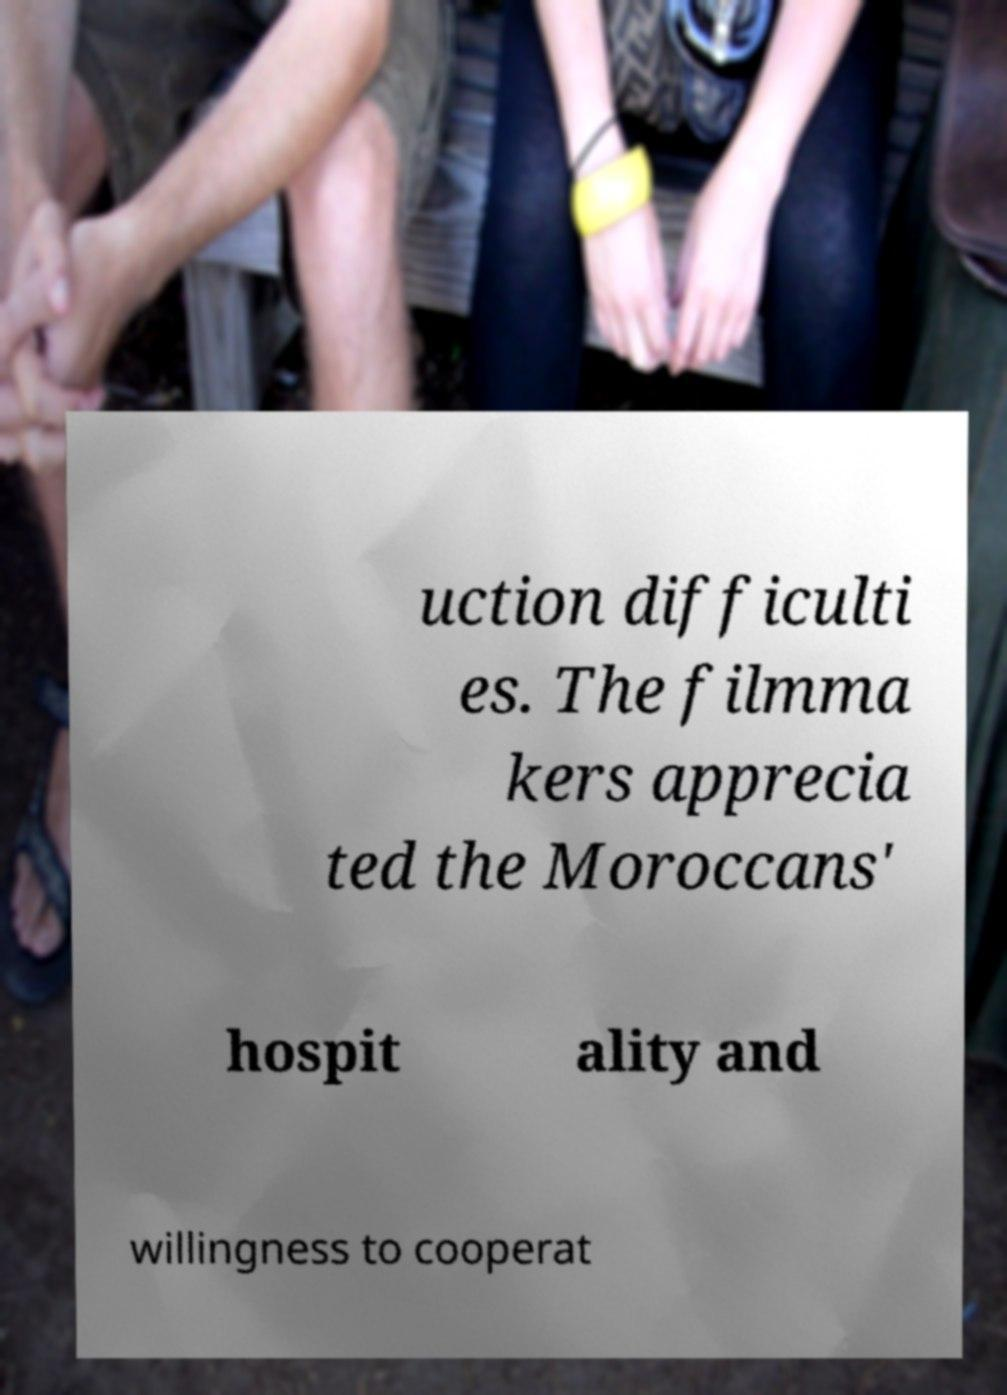I need the written content from this picture converted into text. Can you do that? uction difficulti es. The filmma kers apprecia ted the Moroccans' hospit ality and willingness to cooperat 